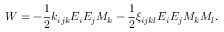<formula> <loc_0><loc_0><loc_500><loc_500>W = - \frac { 1 } { 2 } k _ { i j k } E _ { i } E _ { j } M _ { k } - \frac { 1 } { 2 } \xi _ { i j k l } E _ { i } E _ { j } M _ { k } M _ { l } .</formula> 